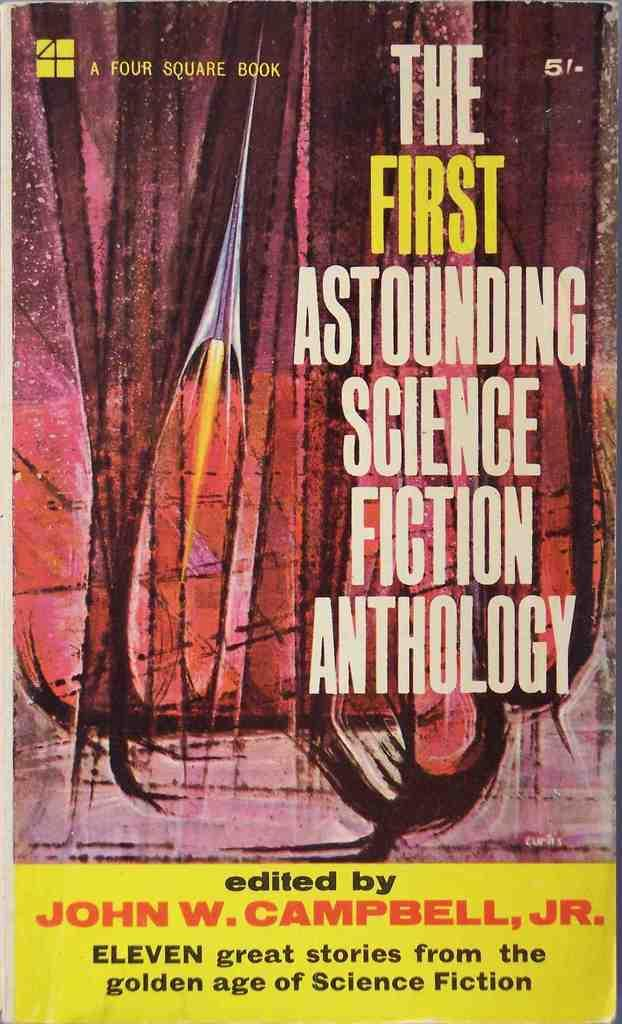What type of visual is depicted in the image? The image is a poster. What can be found on the poster besides the design? There are letters on the poster. Can you describe the design on the poster? Unfortunately, the facts provided do not give a detailed description of the design on the poster. Can you see a pump on the poster? No, there is no pump present on the poster. 